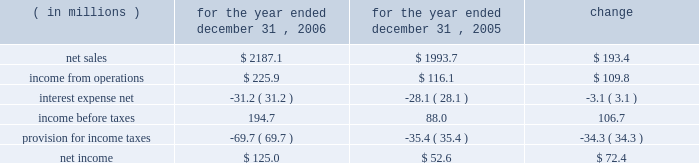Results of operations year ended december 31 , 2006 compared to year ended december 31 , 2005 the historical results of operations of pca for the years ended december 31 , 2006 and 2005 are set forth below : for the year ended december 31 , ( in millions ) 2006 2005 change .
Net sales net sales increased by $ 193.4 million , or 9.7% ( 9.7 % ) , for the year ended december 31 , 2006 from the year ended december 31 , 2005 .
Net sales increased primarily due to increased sales prices and volumes of corrugated products and containerboard compared to 2005 .
Total corrugated products volume sold increased 0.4% ( 0.4 % ) to 31.3 billion square feet in 2006 compared to 31.2 billion square feet in 2005 .
On a comparable shipment-per-workday basis , corrugated products sales volume increased 0.8% ( 0.8 % ) in 2006 from 2005 .
Shipments-per-workday is calculated by dividing our total corrugated products volume during the year by the number of workdays within the year .
The larger percentage increase on a shipment-per-workday basis was due to the fact that 2006 had one less workday ( 249 days ) , those days not falling on a weekend or holiday , than 2005 ( 250 days ) .
Containerboard sales volume to external domestic and export customers increased 15.6% ( 15.6 % ) to 482000 tons for the year ended december 31 , 2006 from 417000 tons in 2005 .
Income from operations income from operations increased by $ 109.8 million , or 94.6% ( 94.6 % ) , for the year ended december 31 , 2006 compared to 2005 .
Included in income from operations for the year ended december 31 , 2005 is income of $ 14.0 million , net of expenses , consisting of two dividends paid to pca by southern timber venture , llc ( stv ) , the timberlands joint venture in which pca owns a 311 20443% ( 20443 % ) ownership interest .
Excluding the dividends from stv , income from operations increased $ 123.8 million in 2006 compared to 2005 .
The $ 123.8 million increase in income from operations was primarily attributable to higher sales prices and volume as well as improved mix of business ( $ 195.6 million ) , partially offset by increased costs related to transportation ( $ 18.9 million ) , energy , primarily purchased fuels and electricity ( $ 18.3 million ) , wage increases for hourly and salaried personnel ( $ 16.9 million ) , medical , pension and other benefit costs ( $ 9.9 million ) , and incentive compensation ( $ 6.5 million ) .
Gross profit increased $ 137.1 million , or 44.7% ( 44.7 % ) , for the year ended december 31 , 2006 from the year ended december 31 , 2005 .
Gross profit as a percentage of net sales increased from 15.4% ( 15.4 % ) of net sales in 2005 to 20.3% ( 20.3 % ) of net sales in the current year primarily due to the increased sales prices described previously .
Selling and administrative expenses increased $ 12.3 million , or 8.4% ( 8.4 % ) , for the year ended december 31 , 2006 from the comparable period in 2005 .
The increase was primarily the result of increased salary and .
What was the operating income margin for 2006? 
Rationale: operating margin comparison point to increasing or decreasing efficiency .
Computations: (225.9 / 2187.1)
Answer: 0.10329. 